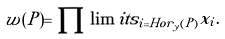<formula> <loc_0><loc_0><loc_500><loc_500>w ( P ) = \prod \lim i t s _ { i = H o r _ { y } ( P ) } x _ { i } .</formula> 